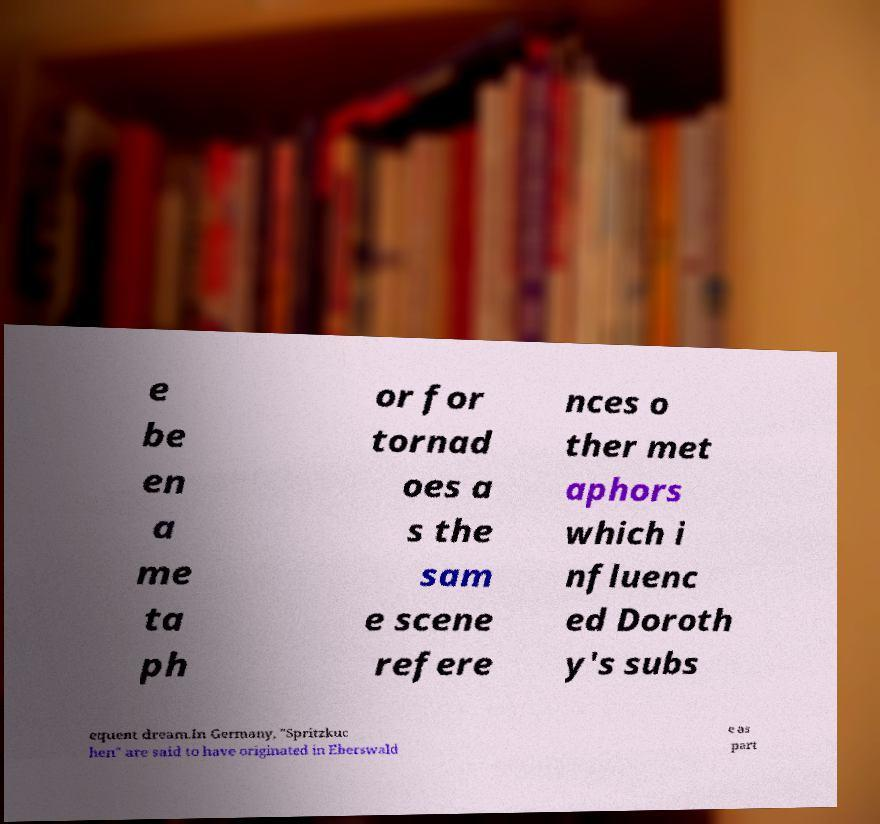What messages or text are displayed in this image? I need them in a readable, typed format. e be en a me ta ph or for tornad oes a s the sam e scene refere nces o ther met aphors which i nfluenc ed Doroth y's subs equent dream.In Germany, "Spritzkuc hen" are said to have originated in Eberswald e as part 